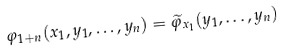Convert formula to latex. <formula><loc_0><loc_0><loc_500><loc_500>\varphi _ { 1 + n } ( x _ { 1 } , y _ { 1 } , \dots , y _ { n } ) = \widetilde { \varphi } _ { x _ { 1 } } ( y _ { 1 } , \dots , y _ { n } )</formula> 